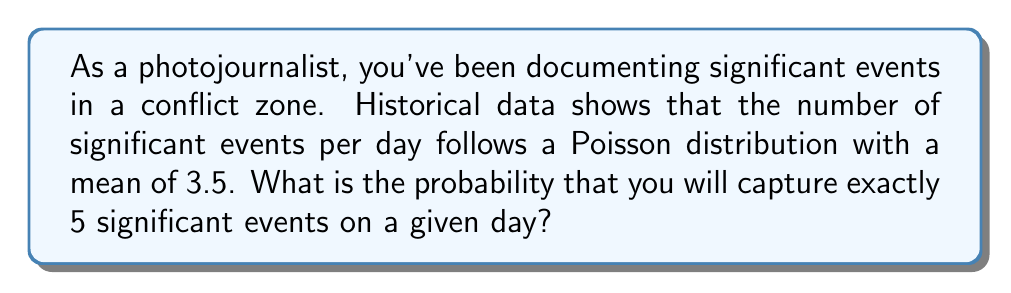Help me with this question. To solve this problem, we'll use the Poisson probability mass function:

$$P(X = k) = \frac{e^{-\lambda}\lambda^k}{k!}$$

Where:
$\lambda$ is the mean number of events per day (3.5)
$k$ is the number of events we're interested in (5)
$e$ is Euler's number (approximately 2.71828)

Let's solve this step-by-step:

1) Substitute the values into the formula:

   $$P(X = 5) = \frac{e^{-3.5}3.5^5}{5!}$$

2) Calculate $e^{-3.5}$:
   $$e^{-3.5} \approx 0.0302419$$

3) Calculate $3.5^5$:
   $$3.5^5 = 525.21875$$

4) Calculate $5!$:
   $$5! = 5 \times 4 \times 3 \times 2 \times 1 = 120$$

5) Now, put it all together:

   $$P(X = 5) = \frac{0.0302419 \times 525.21875}{120}$$

6) Simplify:
   $$P(X = 5) \approx 0.1317$$

Therefore, the probability of capturing exactly 5 significant events on a given day is approximately 0.1317 or 13.17%.
Answer: 0.1317 